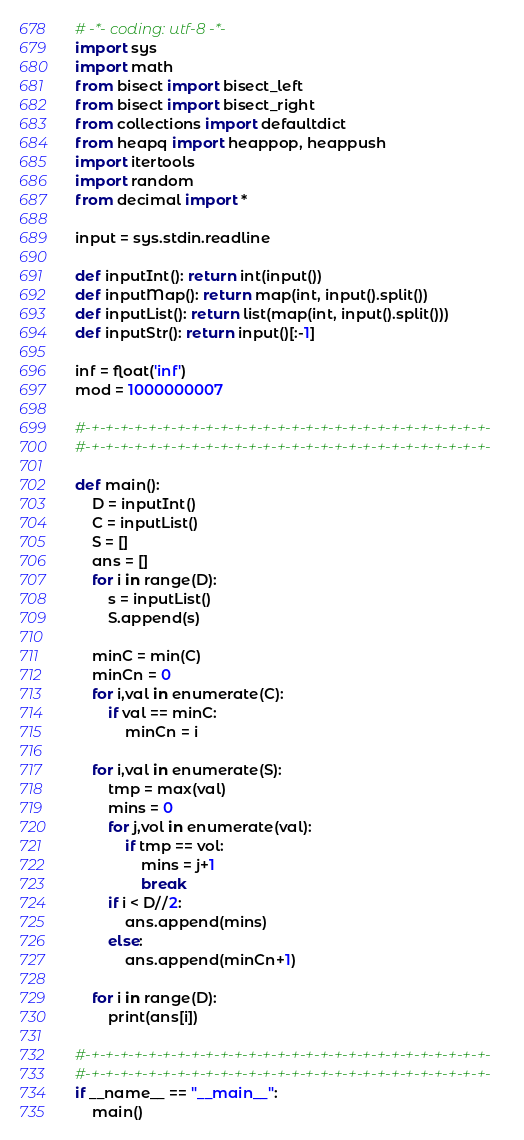Convert code to text. <code><loc_0><loc_0><loc_500><loc_500><_Python_># -*- coding: utf-8 -*-
import sys
import math
from bisect import bisect_left
from bisect import bisect_right
from collections import defaultdict
from heapq import heappop, heappush
import itertools
import random
from decimal import *

input = sys.stdin.readline

def inputInt(): return int(input())
def inputMap(): return map(int, input().split())
def inputList(): return list(map(int, input().split()))
def inputStr(): return input()[:-1]

inf = float('inf')
mod = 1000000007

#-+-+-+-+-+-+-+-+-+-+-+-+-+-+-+-+-+-+-+-+-+-+-+-+-+-+-+-+-
#-+-+-+-+-+-+-+-+-+-+-+-+-+-+-+-+-+-+-+-+-+-+-+-+-+-+-+-+-

def main():
	D = inputInt()
	C = inputList()
	S = []
	ans = []
	for i in range(D):
		s = inputList()
		S.append(s)

	minC = min(C)
	minCn = 0
	for i,val in enumerate(C):
		if val == minC:
			minCn = i

	for i,val in enumerate(S):
		tmp = max(val)
		mins = 0
		for j,vol in enumerate(val):
			if tmp == vol:
				mins = j+1
				break
		if i < D//2:
			ans.append(mins)
		else:
			ans.append(minCn+1)

	for i in range(D):
		print(ans[i])

#-+-+-+-+-+-+-+-+-+-+-+-+-+-+-+-+-+-+-+-+-+-+-+-+-+-+-+-+-
#-+-+-+-+-+-+-+-+-+-+-+-+-+-+-+-+-+-+-+-+-+-+-+-+-+-+-+-+-
if __name__ == "__main__":
	main()
</code> 